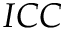Convert formula to latex. <formula><loc_0><loc_0><loc_500><loc_500>I C C</formula> 